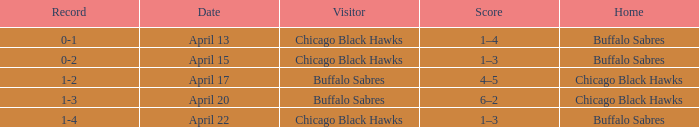Name the Visitor that has a Home of chicago black hawks on april 20? Buffalo Sabres. Parse the full table. {'header': ['Record', 'Date', 'Visitor', 'Score', 'Home'], 'rows': [['0-1', 'April 13', 'Chicago Black Hawks', '1–4', 'Buffalo Sabres'], ['0-2', 'April 15', 'Chicago Black Hawks', '1–3', 'Buffalo Sabres'], ['1-2', 'April 17', 'Buffalo Sabres', '4–5', 'Chicago Black Hawks'], ['1-3', 'April 20', 'Buffalo Sabres', '6–2', 'Chicago Black Hawks'], ['1-4', 'April 22', 'Chicago Black Hawks', '1–3', 'Buffalo Sabres']]} 